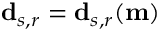<formula> <loc_0><loc_0><loc_500><loc_500>d _ { s , r } = d _ { s , r } ( m )</formula> 